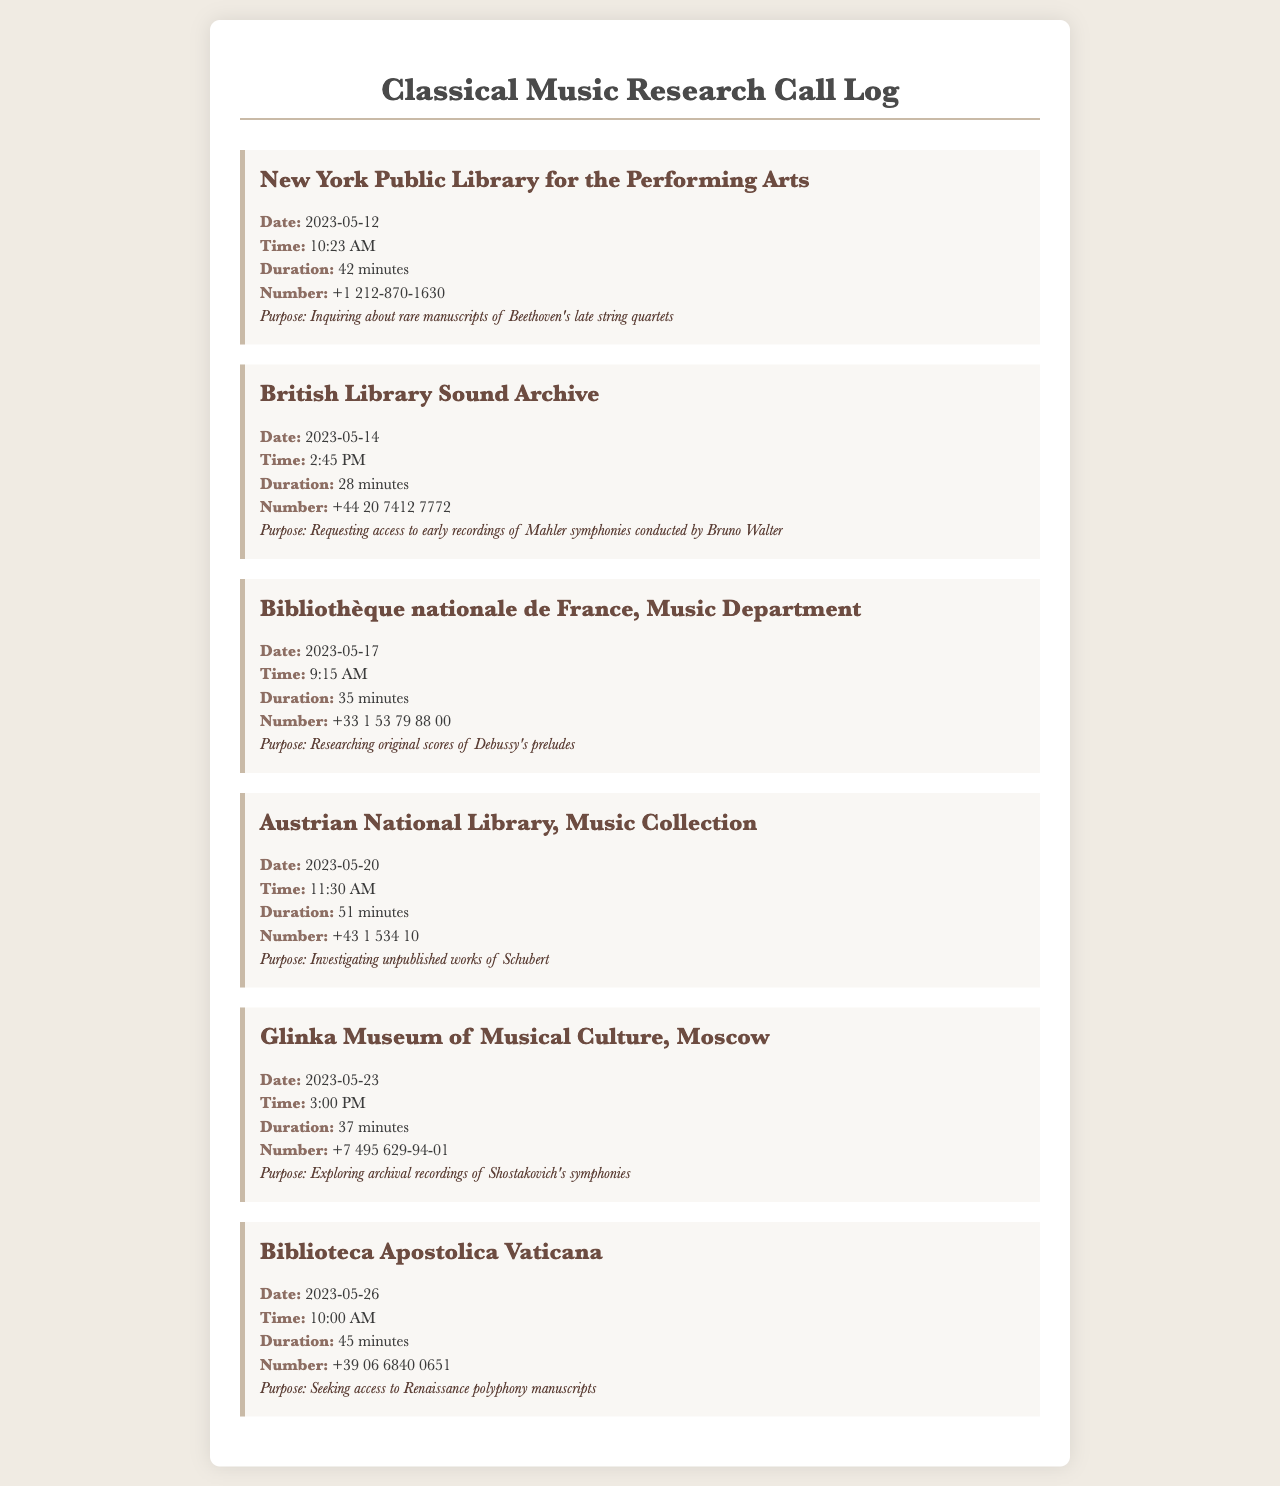what date was the call made to the Austrian National Library? The date of the call can be found in the record for the Austrian National Library, which states it was made on 2023-05-20.
Answer: 2023-05-20 how long was the call to the Glinka Museum of Musical Culture? The duration is listed in the record for Glinka Museum of Musical Culture, indicating the call lasted 37 minutes.
Answer: 37 minutes which institution was contacted on May 14th? The record indicates that on May 14th, the call was made to the British Library Sound Archive.
Answer: British Library Sound Archive how many total calls were made to music libraries and archives in May 2023? By reviewing the document, we count the number of records, which shows that there were a total of 6 calls made in May 2023.
Answer: 6 what time was the call to the New York Public Library for the Performing Arts? The time is recorded in the New York Public Library entry, detailing that the call was made at 10:23 AM.
Answer: 10:23 AM what was the main topic of research during the call to the Bibliothèque nationale de France? The record specifies the main topic of research during that call was original scores of Debussy's preludes.
Answer: original scores of Debussy's preludes 